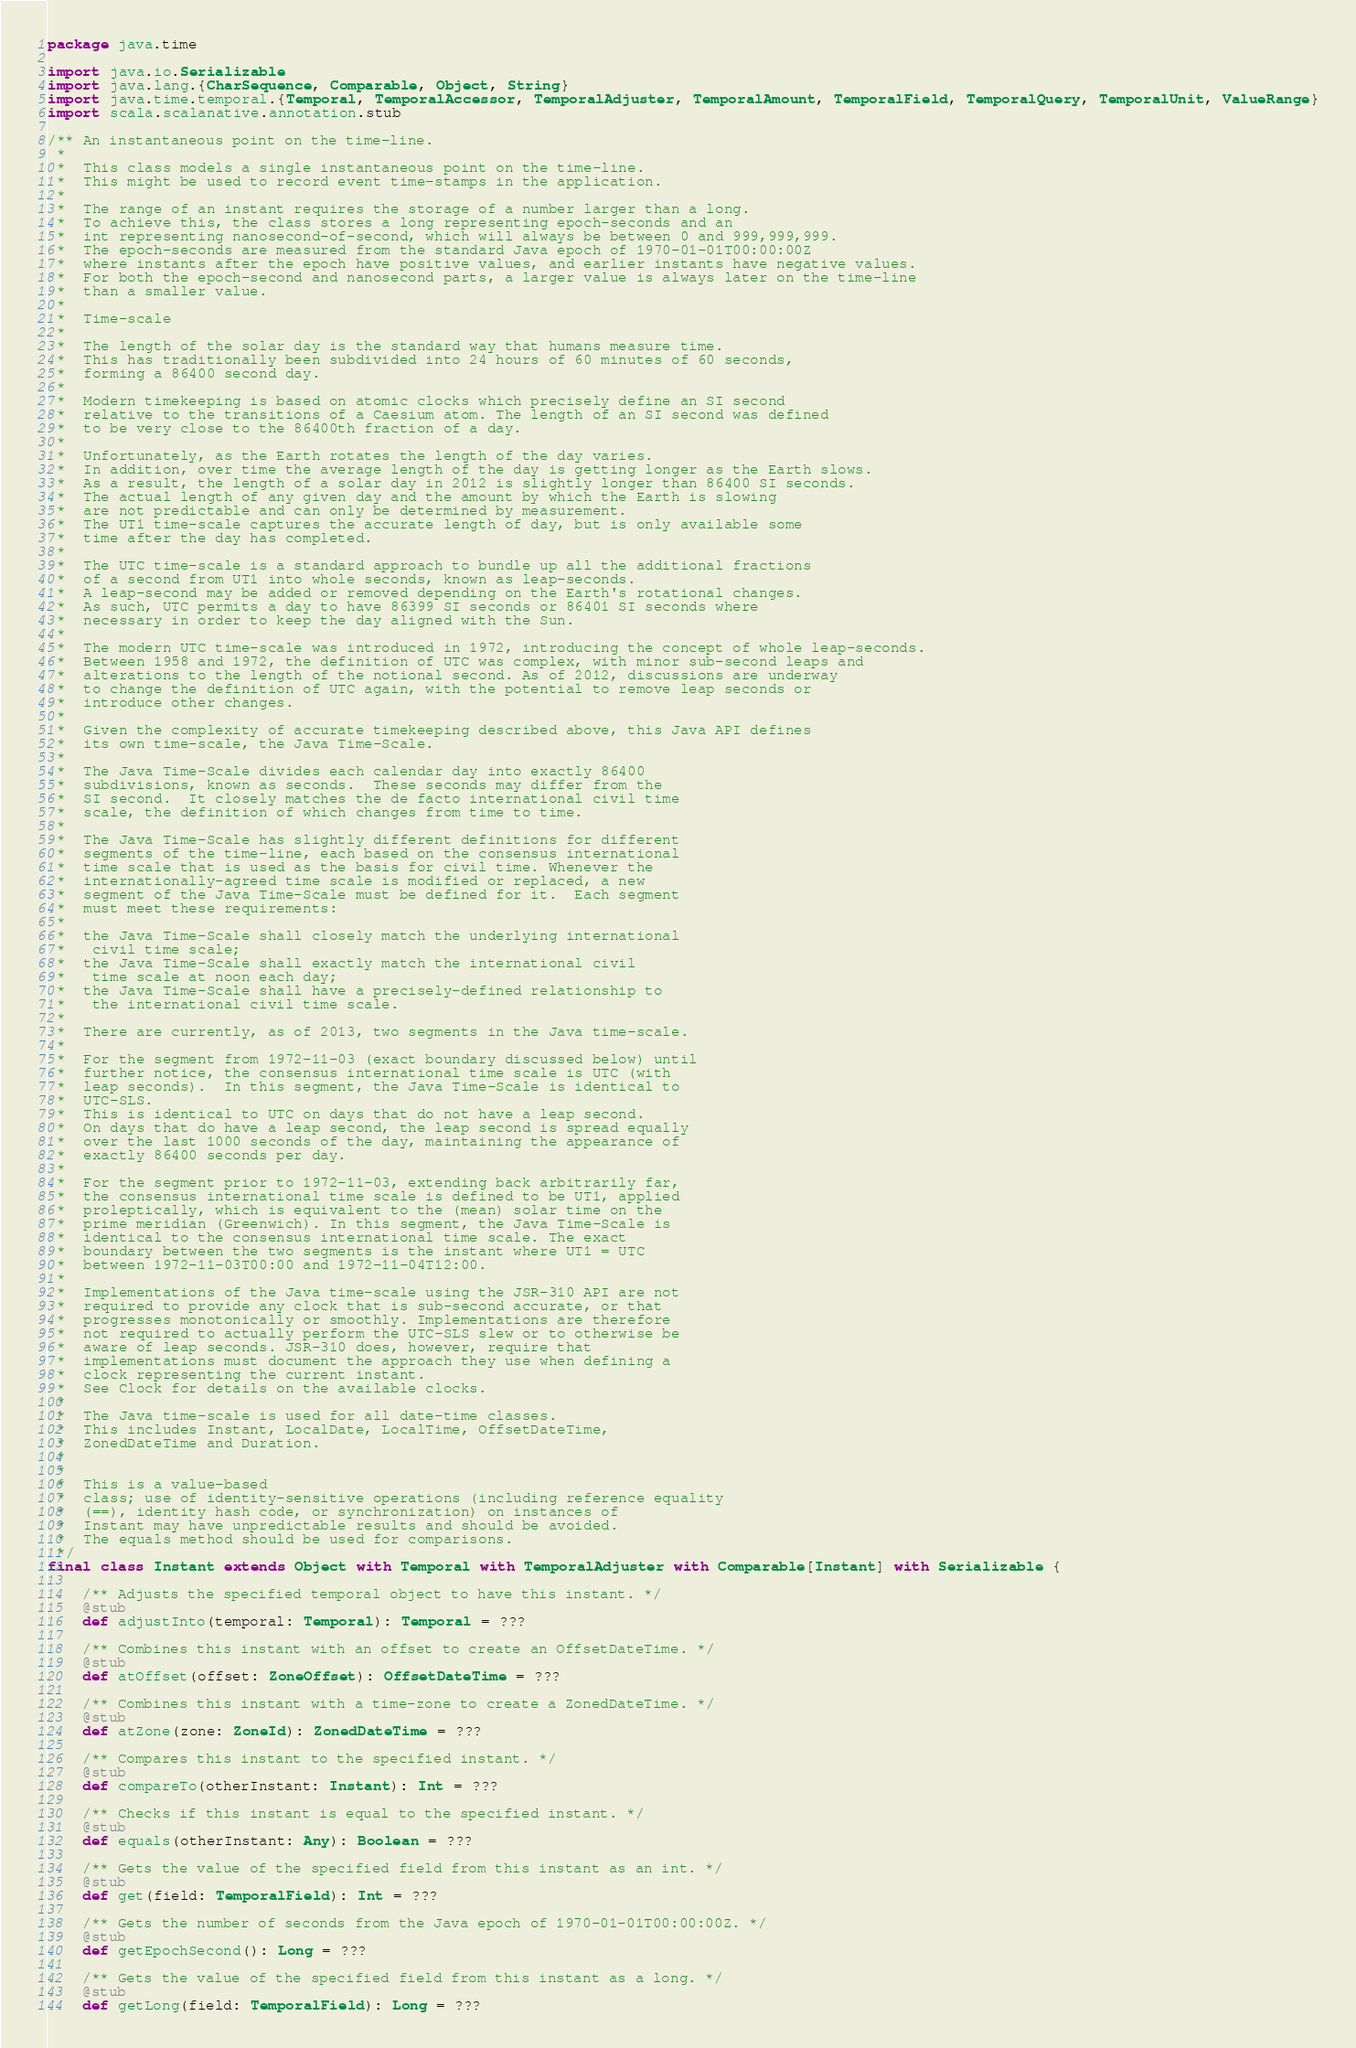Convert code to text. <code><loc_0><loc_0><loc_500><loc_500><_Scala_>package java.time

import java.io.Serializable
import java.lang.{CharSequence, Comparable, Object, String}
import java.time.temporal.{Temporal, TemporalAccessor, TemporalAdjuster, TemporalAmount, TemporalField, TemporalQuery, TemporalUnit, ValueRange}
import scala.scalanative.annotation.stub

/** An instantaneous point on the time-line.
 *  
 *  This class models a single instantaneous point on the time-line.
 *  This might be used to record event time-stamps in the application.
 *  
 *  The range of an instant requires the storage of a number larger than a long.
 *  To achieve this, the class stores a long representing epoch-seconds and an
 *  int representing nanosecond-of-second, which will always be between 0 and 999,999,999.
 *  The epoch-seconds are measured from the standard Java epoch of 1970-01-01T00:00:00Z
 *  where instants after the epoch have positive values, and earlier instants have negative values.
 *  For both the epoch-second and nanosecond parts, a larger value is always later on the time-line
 *  than a smaller value.
 * 
 *  Time-scale
 *  
 *  The length of the solar day is the standard way that humans measure time.
 *  This has traditionally been subdivided into 24 hours of 60 minutes of 60 seconds,
 *  forming a 86400 second day.
 *  
 *  Modern timekeeping is based on atomic clocks which precisely define an SI second
 *  relative to the transitions of a Caesium atom. The length of an SI second was defined
 *  to be very close to the 86400th fraction of a day.
 *  
 *  Unfortunately, as the Earth rotates the length of the day varies.
 *  In addition, over time the average length of the day is getting longer as the Earth slows.
 *  As a result, the length of a solar day in 2012 is slightly longer than 86400 SI seconds.
 *  The actual length of any given day and the amount by which the Earth is slowing
 *  are not predictable and can only be determined by measurement.
 *  The UT1 time-scale captures the accurate length of day, but is only available some
 *  time after the day has completed.
 *  
 *  The UTC time-scale is a standard approach to bundle up all the additional fractions
 *  of a second from UT1 into whole seconds, known as leap-seconds.
 *  A leap-second may be added or removed depending on the Earth's rotational changes.
 *  As such, UTC permits a day to have 86399 SI seconds or 86401 SI seconds where
 *  necessary in order to keep the day aligned with the Sun.
 *  
 *  The modern UTC time-scale was introduced in 1972, introducing the concept of whole leap-seconds.
 *  Between 1958 and 1972, the definition of UTC was complex, with minor sub-second leaps and
 *  alterations to the length of the notional second. As of 2012, discussions are underway
 *  to change the definition of UTC again, with the potential to remove leap seconds or
 *  introduce other changes.
 *  
 *  Given the complexity of accurate timekeeping described above, this Java API defines
 *  its own time-scale, the Java Time-Scale.
 *  
 *  The Java Time-Scale divides each calendar day into exactly 86400
 *  subdivisions, known as seconds.  These seconds may differ from the
 *  SI second.  It closely matches the de facto international civil time
 *  scale, the definition of which changes from time to time.
 *  
 *  The Java Time-Scale has slightly different definitions for different
 *  segments of the time-line, each based on the consensus international
 *  time scale that is used as the basis for civil time. Whenever the
 *  internationally-agreed time scale is modified or replaced, a new
 *  segment of the Java Time-Scale must be defined for it.  Each segment
 *  must meet these requirements:
 *  
 *  the Java Time-Scale shall closely match the underlying international
 *   civil time scale;
 *  the Java Time-Scale shall exactly match the international civil
 *   time scale at noon each day;
 *  the Java Time-Scale shall have a precisely-defined relationship to
 *   the international civil time scale.
 *  
 *  There are currently, as of 2013, two segments in the Java time-scale.
 *  
 *  For the segment from 1972-11-03 (exact boundary discussed below) until
 *  further notice, the consensus international time scale is UTC (with
 *  leap seconds).  In this segment, the Java Time-Scale is identical to
 *  UTC-SLS.
 *  This is identical to UTC on days that do not have a leap second.
 *  On days that do have a leap second, the leap second is spread equally
 *  over the last 1000 seconds of the day, maintaining the appearance of
 *  exactly 86400 seconds per day.
 *  
 *  For the segment prior to 1972-11-03, extending back arbitrarily far,
 *  the consensus international time scale is defined to be UT1, applied
 *  proleptically, which is equivalent to the (mean) solar time on the
 *  prime meridian (Greenwich). In this segment, the Java Time-Scale is
 *  identical to the consensus international time scale. The exact
 *  boundary between the two segments is the instant where UT1 = UTC
 *  between 1972-11-03T00:00 and 1972-11-04T12:00.
 *  
 *  Implementations of the Java time-scale using the JSR-310 API are not
 *  required to provide any clock that is sub-second accurate, or that
 *  progresses monotonically or smoothly. Implementations are therefore
 *  not required to actually perform the UTC-SLS slew or to otherwise be
 *  aware of leap seconds. JSR-310 does, however, require that
 *  implementations must document the approach they use when defining a
 *  clock representing the current instant.
 *  See Clock for details on the available clocks.
 *  
 *  The Java time-scale is used for all date-time classes.
 *  This includes Instant, LocalDate, LocalTime, OffsetDateTime,
 *  ZonedDateTime and Duration.
 * 
 *  
 *  This is a value-based
 *  class; use of identity-sensitive operations (including reference equality
 *  (==), identity hash code, or synchronization) on instances of
 *  Instant may have unpredictable results and should be avoided.
 *  The equals method should be used for comparisons.
 */
final class Instant extends Object with Temporal with TemporalAdjuster with Comparable[Instant] with Serializable {

    /** Adjusts the specified temporal object to have this instant. */
    @stub
    def adjustInto(temporal: Temporal): Temporal = ???

    /** Combines this instant with an offset to create an OffsetDateTime. */
    @stub
    def atOffset(offset: ZoneOffset): OffsetDateTime = ???

    /** Combines this instant with a time-zone to create a ZonedDateTime. */
    @stub
    def atZone(zone: ZoneId): ZonedDateTime = ???

    /** Compares this instant to the specified instant. */
    @stub
    def compareTo(otherInstant: Instant): Int = ???

    /** Checks if this instant is equal to the specified instant. */
    @stub
    def equals(otherInstant: Any): Boolean = ???

    /** Gets the value of the specified field from this instant as an int. */
    @stub
    def get(field: TemporalField): Int = ???

    /** Gets the number of seconds from the Java epoch of 1970-01-01T00:00:00Z. */
    @stub
    def getEpochSecond(): Long = ???

    /** Gets the value of the specified field from this instant as a long. */
    @stub
    def getLong(field: TemporalField): Long = ???
</code> 